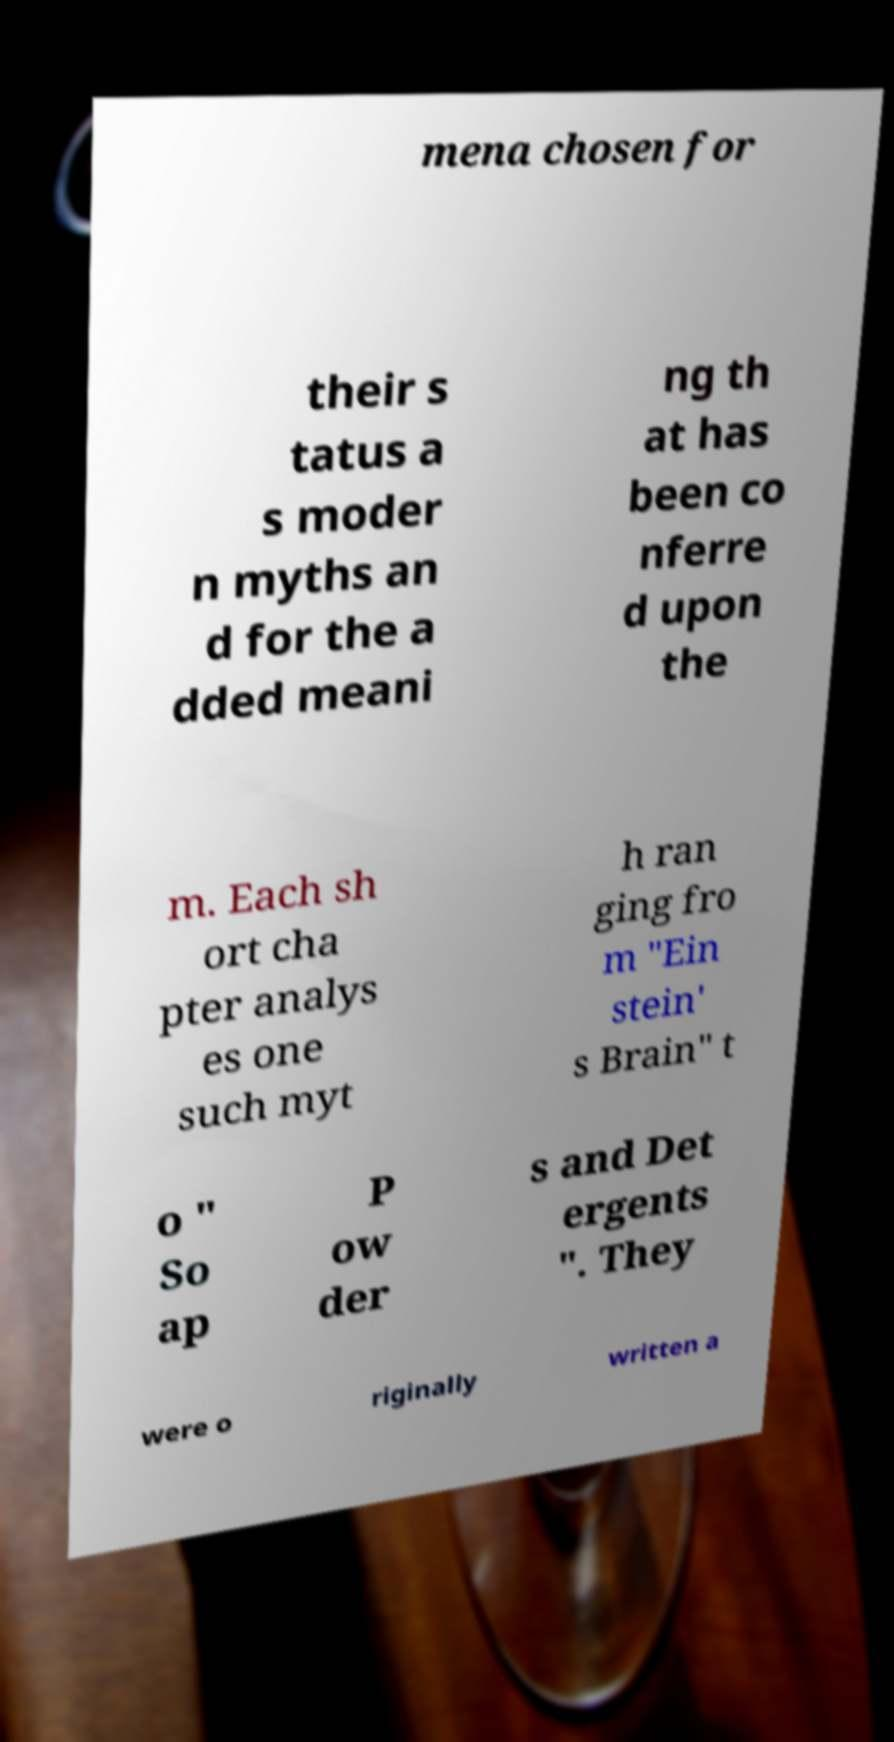For documentation purposes, I need the text within this image transcribed. Could you provide that? mena chosen for their s tatus a s moder n myths an d for the a dded meani ng th at has been co nferre d upon the m. Each sh ort cha pter analys es one such myt h ran ging fro m "Ein stein' s Brain" t o " So ap P ow der s and Det ergents ". They were o riginally written a 